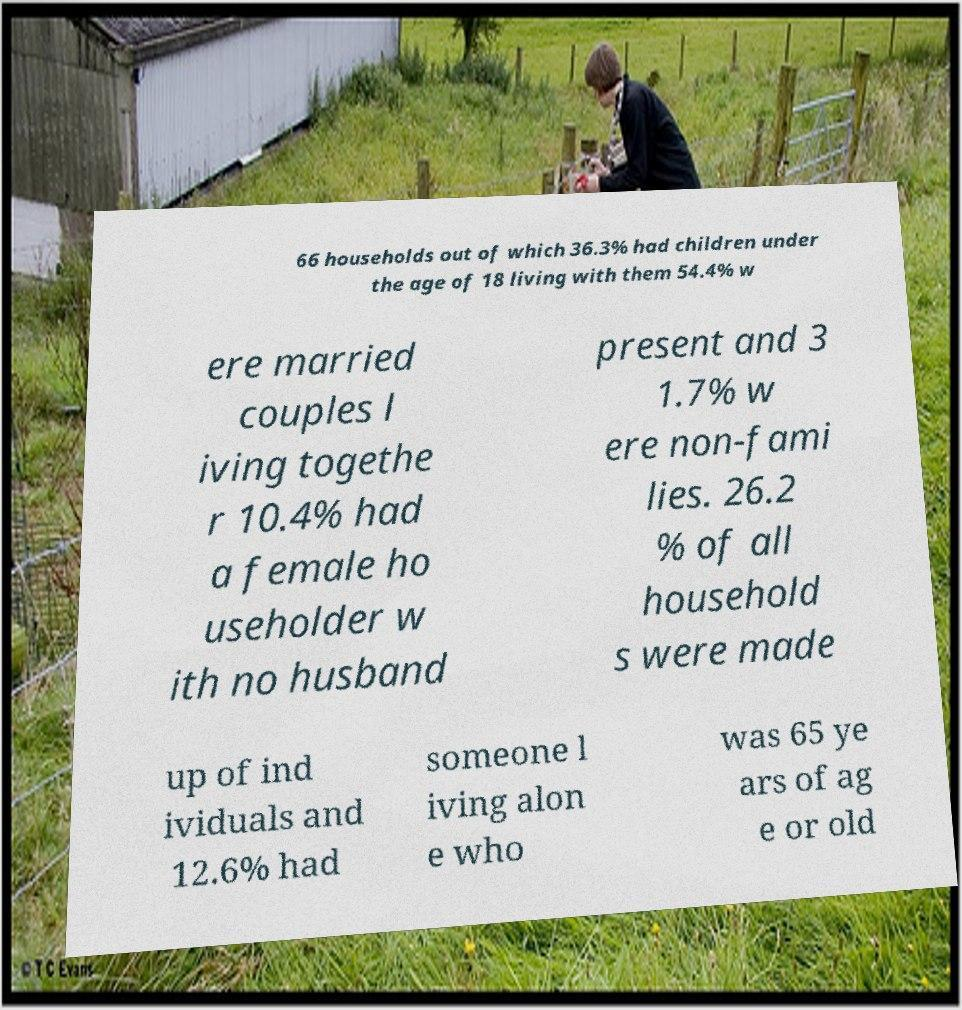Could you extract and type out the text from this image? 66 households out of which 36.3% had children under the age of 18 living with them 54.4% w ere married couples l iving togethe r 10.4% had a female ho useholder w ith no husband present and 3 1.7% w ere non-fami lies. 26.2 % of all household s were made up of ind ividuals and 12.6% had someone l iving alon e who was 65 ye ars of ag e or old 